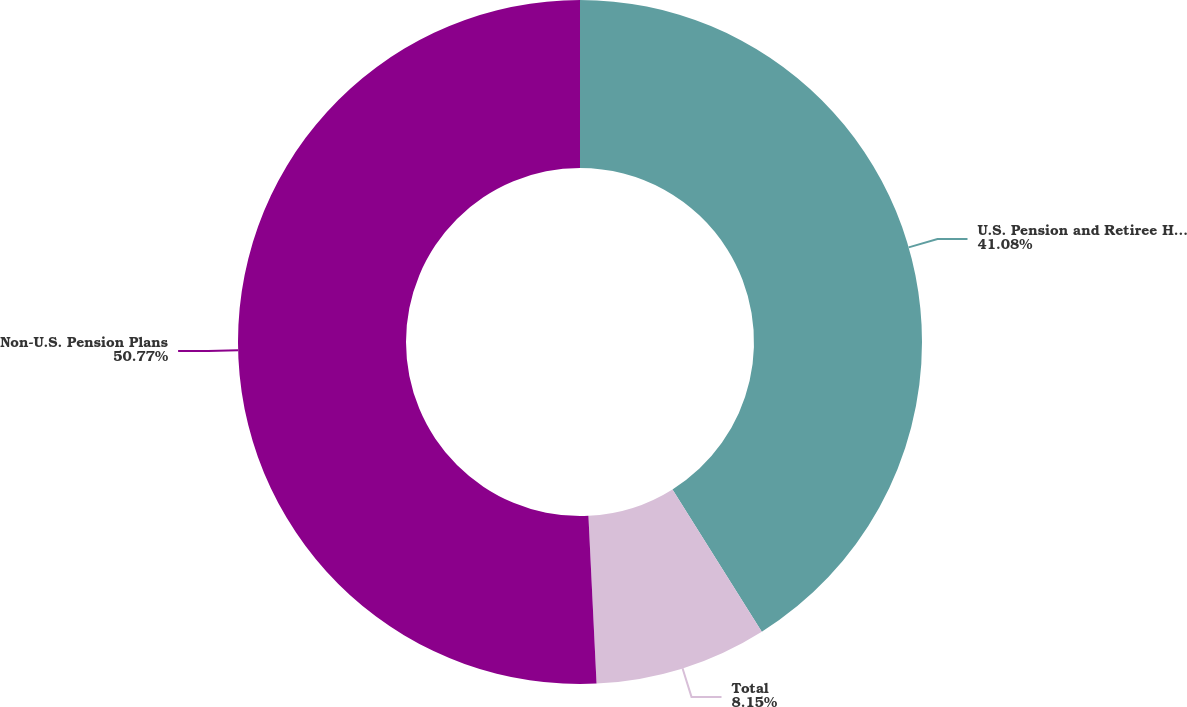<chart> <loc_0><loc_0><loc_500><loc_500><pie_chart><fcel>U.S. Pension and Retiree Healthcare Plans<fcel>Total<fcel>Non-U.S. Pension Plans<nl><fcel>41.08%<fcel>8.15%<fcel>50.77%<nl></chart> 